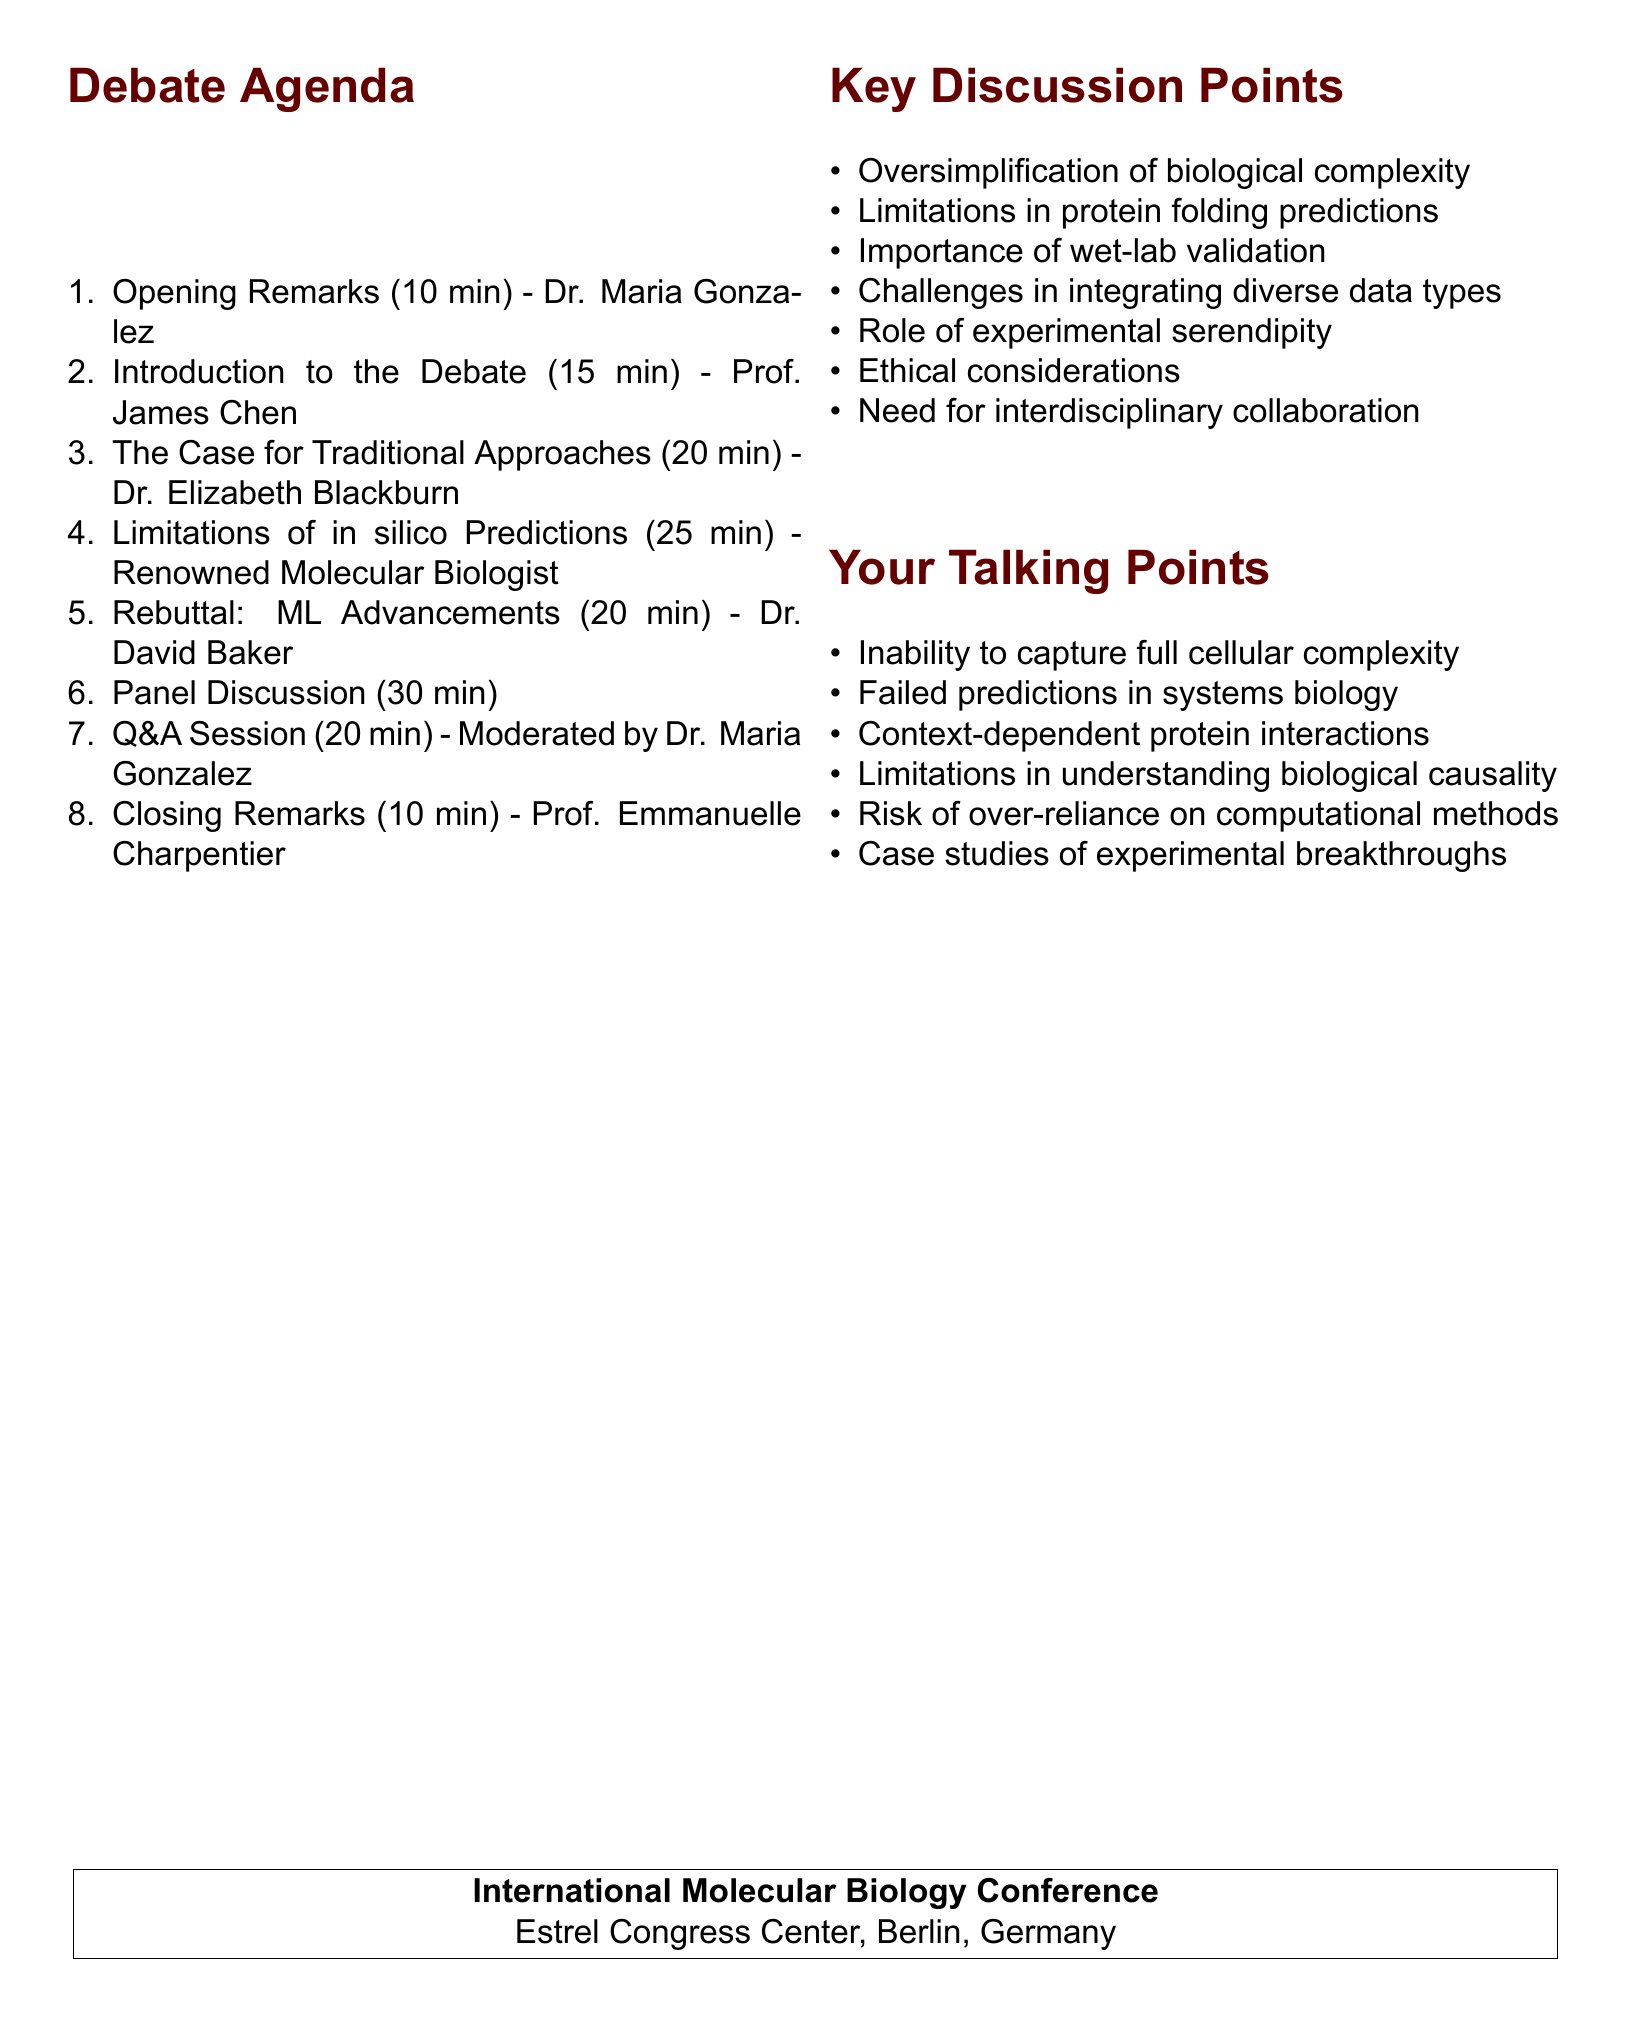What is the date of the conference? The date of the conference is mentioned clearly in the document.
Answer: September 15-17, 2023 Who is the speaker for the opening remarks? The document lists the speakers for each agenda item, including the opening remarks.
Answer: Dr. Maria Gonzalez How long is the panel discussion scheduled for? The duration of each agenda item is provided, allowing us to find the duration of the panel discussion.
Answer: 30 minutes What is the title of your presentation? The title of the presentation is explicitly stated in the agenda items.
Answer: Limitations of in silico Predictions in Complex Biological Systems Who is moderating the Q&A session? The document specifies the moderator for the Q&A session in the agenda.
Answer: Dr. Maria Gonzalez What is one of the key discussion points? The document lists various key discussion points relevant to the debate.
Answer: Oversimplification of biological complexity Which university is Dr. David Baker affiliated with? The affiliations of the speakers are included in the document, which helps identify the university associated with Dr. Baker.
Answer: University of Washington How long are the closing remarks scheduled to last? The time allocated for each session is provided, including closing remarks.
Answer: 10 minutes 